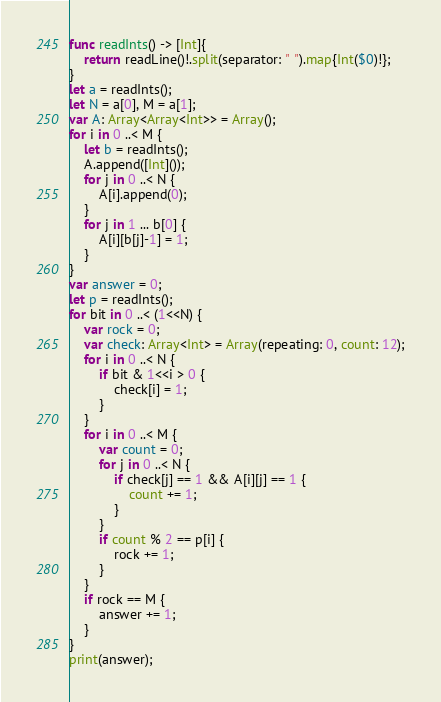<code> <loc_0><loc_0><loc_500><loc_500><_Swift_>func readInts() -> [Int]{
    return readLine()!.split(separator: " ").map{Int($0)!};
}
let a = readInts();
let N = a[0], M = a[1];
var A: Array<Array<Int>> = Array();
for i in 0 ..< M {
    let b = readInts();
    A.append([Int]());
    for j in 0 ..< N {
        A[i].append(0);
    }
    for j in 1 ... b[0] {
        A[i][b[j]-1] = 1;
    }
}
var answer = 0;
let p = readInts();
for bit in 0 ..< (1<<N) {
    var rock = 0;
    var check: Array<Int> = Array(repeating: 0, count: 12);
    for i in 0 ..< N {
        if bit & 1<<i > 0 {
            check[i] = 1;
        }
    }
    for i in 0 ..< M {
        var count = 0;
        for j in 0 ..< N {
            if check[j] == 1 && A[i][j] == 1 {
                count += 1;
            }
        }
        if count % 2 == p[i] {
            rock += 1;
        }
    }
    if rock == M {
        answer += 1;
    }
}
print(answer);</code> 